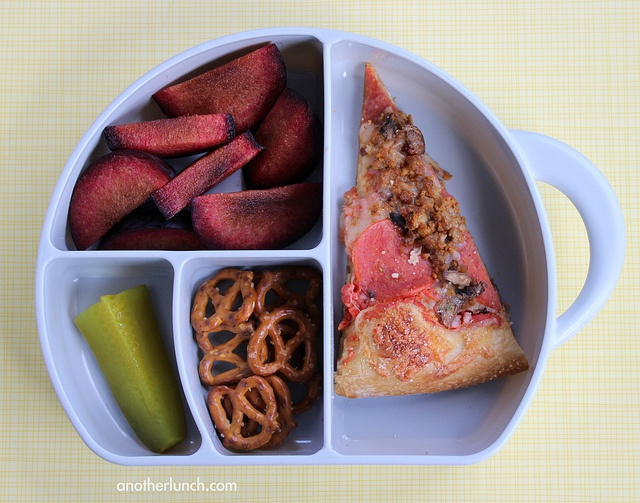Describe the objects in this image and their specific colors. I can see a pizza in beige, brown, salmon, lightpink, and maroon tones in this image. 